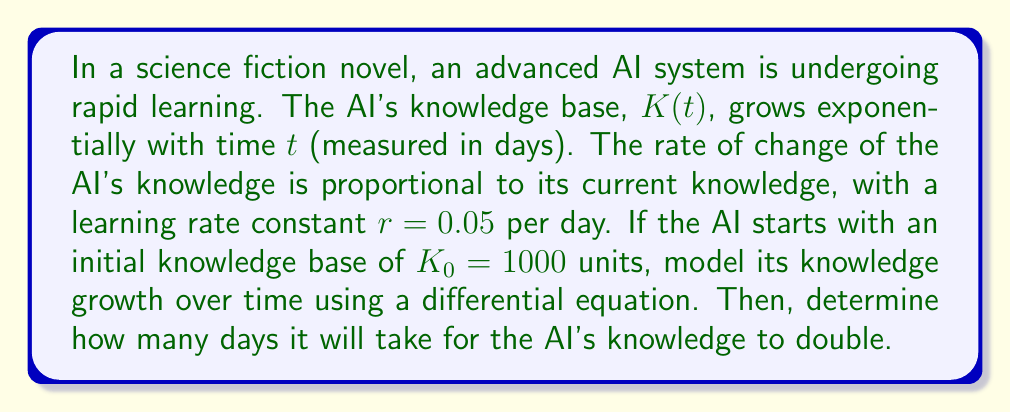Help me with this question. To model the AI's knowledge growth, we can use an exponential growth differential equation:

1) The rate of change of knowledge with respect to time is given by:

   $$\frac{dK}{dt} = rK$$

   where $r = 0.05$ is the learning rate constant.

2) This differential equation can be solved using separation of variables:

   $$\frac{dK}{K} = rdt$$

3) Integrating both sides:

   $$\int \frac{dK}{K} = \int rdt$$

   $$\ln|K| = rt + C$$

4) Solving for $K$:

   $$K = e^{rt + C} = e^C \cdot e^{rt} = K_0 \cdot e^{rt}$$

   where $K_0 = 1000$ is the initial knowledge.

5) Therefore, the knowledge growth model is:

   $$K(t) = 1000 \cdot e^{0.05t}$$

6) To find when the knowledge doubles, we set $K(t) = 2K_0 = 2000$:

   $$2000 = 1000 \cdot e^{0.05t}$$

7) Solving for $t$:

   $$2 = e^{0.05t}$$
   $$\ln(2) = 0.05t$$
   $$t = \frac{\ln(2)}{0.05} \approx 13.86$$

Thus, it will take approximately 13.86 days for the AI's knowledge to double.
Answer: The AI's knowledge growth can be modeled by the equation $K(t) = 1000 \cdot e^{0.05t}$, and it will take approximately 13.86 days for the AI's knowledge to double. 